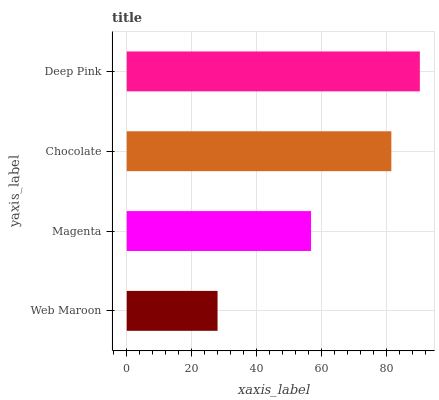Is Web Maroon the minimum?
Answer yes or no. Yes. Is Deep Pink the maximum?
Answer yes or no. Yes. Is Magenta the minimum?
Answer yes or no. No. Is Magenta the maximum?
Answer yes or no. No. Is Magenta greater than Web Maroon?
Answer yes or no. Yes. Is Web Maroon less than Magenta?
Answer yes or no. Yes. Is Web Maroon greater than Magenta?
Answer yes or no. No. Is Magenta less than Web Maroon?
Answer yes or no. No. Is Chocolate the high median?
Answer yes or no. Yes. Is Magenta the low median?
Answer yes or no. Yes. Is Web Maroon the high median?
Answer yes or no. No. Is Chocolate the low median?
Answer yes or no. No. 